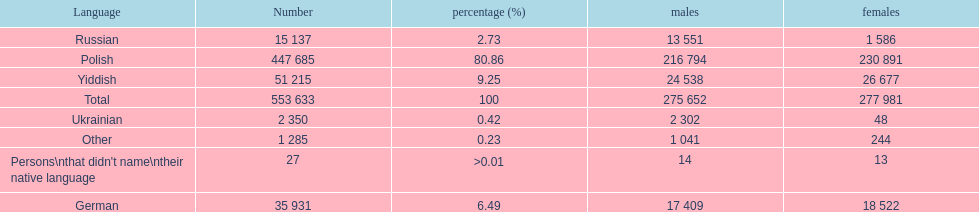How many speakers (of any language) are represented on the table ? 553 633. 